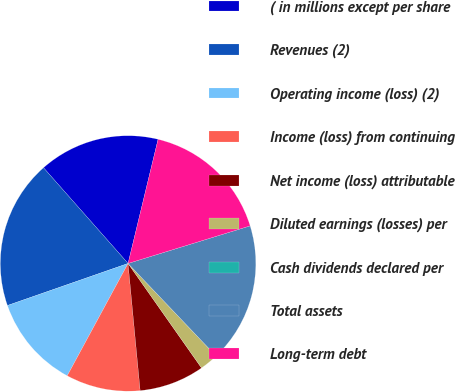<chart> <loc_0><loc_0><loc_500><loc_500><pie_chart><fcel>( in millions except per share<fcel>Revenues (2)<fcel>Operating income (loss) (2)<fcel>Income (loss) from continuing<fcel>Net income (loss) attributable<fcel>Diluted earnings (losses) per<fcel>Cash dividends declared per<fcel>Total assets<fcel>Long-term debt<nl><fcel>15.29%<fcel>18.82%<fcel>11.76%<fcel>9.41%<fcel>8.24%<fcel>2.35%<fcel>0.0%<fcel>17.65%<fcel>16.47%<nl></chart> 